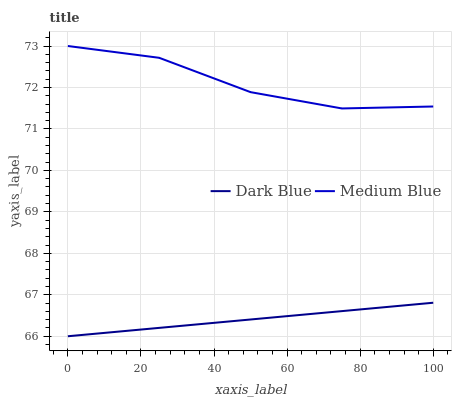Does Medium Blue have the minimum area under the curve?
Answer yes or no. No. Is Medium Blue the smoothest?
Answer yes or no. No. Does Medium Blue have the lowest value?
Answer yes or no. No. Is Dark Blue less than Medium Blue?
Answer yes or no. Yes. Is Medium Blue greater than Dark Blue?
Answer yes or no. Yes. Does Dark Blue intersect Medium Blue?
Answer yes or no. No. 